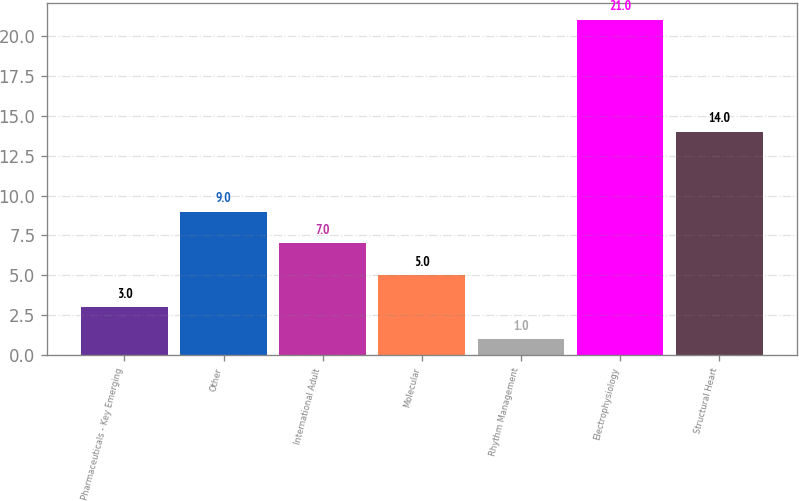<chart> <loc_0><loc_0><loc_500><loc_500><bar_chart><fcel>Pharmaceuticals - Key Emerging<fcel>Other<fcel>International Adult<fcel>Molecular<fcel>Rhythm Management<fcel>Electrophysiology<fcel>Structural Heart<nl><fcel>3<fcel>9<fcel>7<fcel>5<fcel>1<fcel>21<fcel>14<nl></chart> 